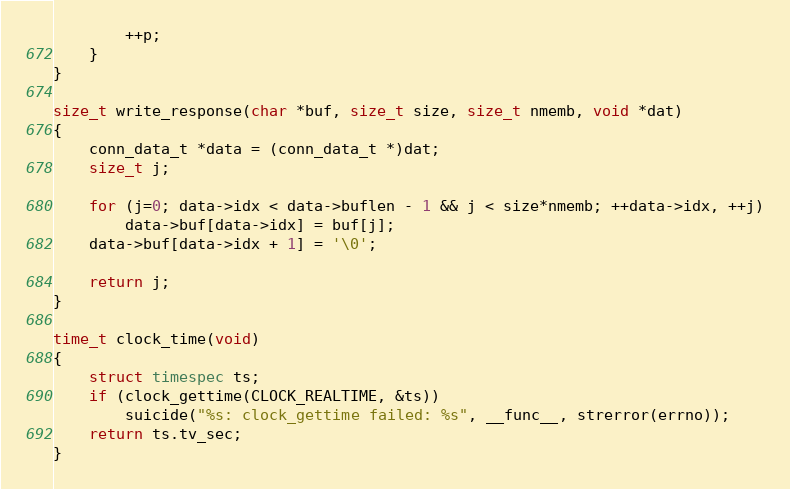<code> <loc_0><loc_0><loc_500><loc_500><_C_>        ++p;
    }
}

size_t write_response(char *buf, size_t size, size_t nmemb, void *dat)
{
    conn_data_t *data = (conn_data_t *)dat;
    size_t j;

    for (j=0; data->idx < data->buflen - 1 && j < size*nmemb; ++data->idx, ++j)
        data->buf[data->idx] = buf[j];
    data->buf[data->idx + 1] = '\0';

    return j;
}

time_t clock_time(void)
{
    struct timespec ts;
    if (clock_gettime(CLOCK_REALTIME, &ts))
        suicide("%s: clock_gettime failed: %s", __func__, strerror(errno));
    return ts.tv_sec;
}

</code> 